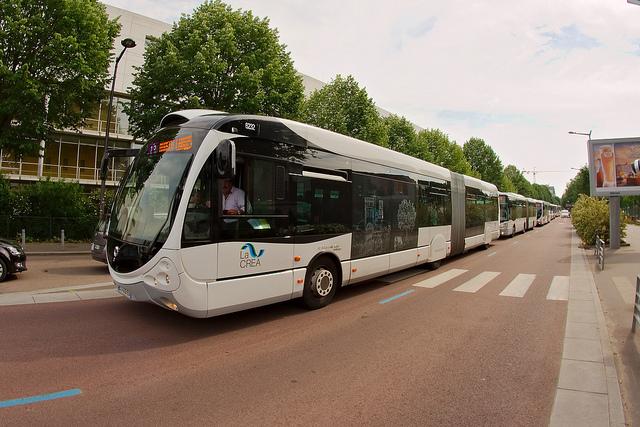Where is the entrance door to the bus?
Give a very brief answer. Right side. Is this a winter scene?
Write a very short answer. No. Can you see the bus driver?
Write a very short answer. Yes. How many white wide stripes is there?
Write a very short answer. 4. Who is in the driver's seat?
Answer briefly. Bus driver. Where could there be a red suitcase?
Short answer required. Bus. 